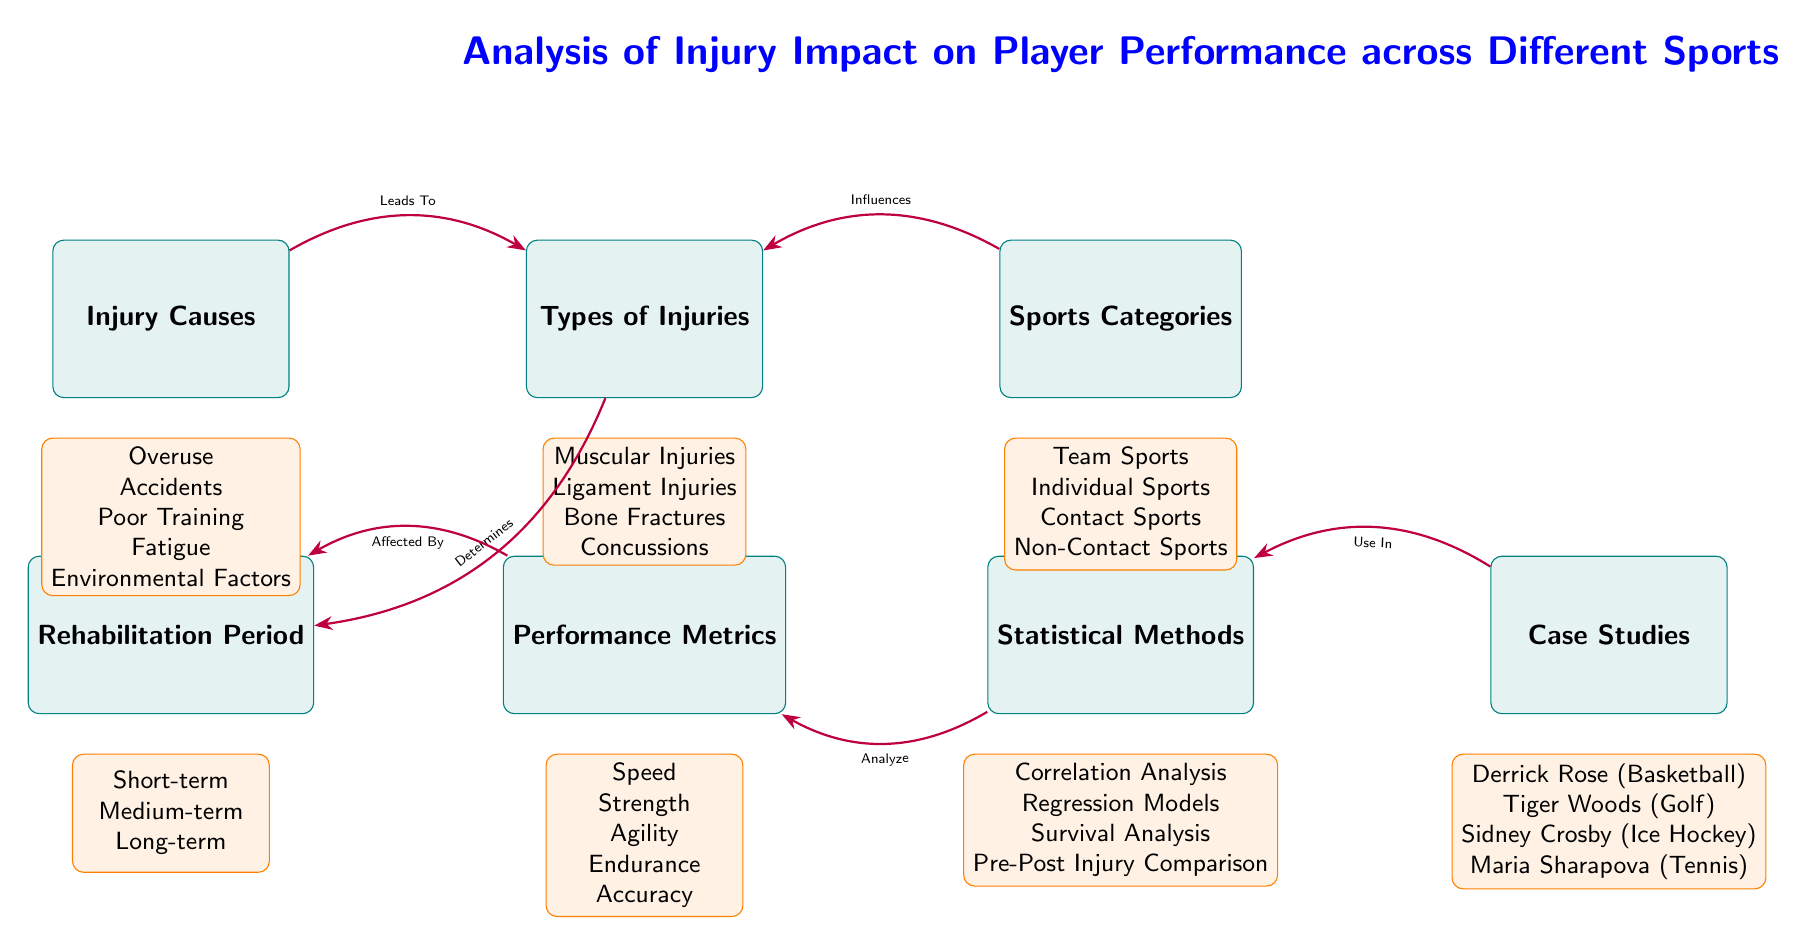What are the types of injuries mentioned in the diagram? The diagram lists four types of injuries: Muscular Injuries, Ligament Injuries, Bone Fractures, and Concussions.
Answer: Muscular Injuries, Ligament Injuries, Bone Fractures, Concussions How many sports categories are identified? The diagram identifies four sports categories: Team Sports, Individual Sports, Contact Sports, and Non-Contact Sports.
Answer: Four What performance metrics are affected by injuries? The diagram details five performance metrics: Speed, Strength, Agility, Endurance, and Accuracy.
Answer: Speed, Strength, Agility, Endurance, Accuracy What leads to injuries according to the diagram? The diagram shows that the causes of injuries include Overuse, Accidents, Poor Training, Fatigue, and Environmental Factors.
Answer: Overuse, Accidents, Poor Training, Fatigue, Environmental Factors How does rehabilitation period relate to performance metrics? The rehabilitation period affects performance metrics, which are also influenced by the types of injuries sustained. This relationship indicates that different rehabilitation approaches can impact various aspects of player performance.
Answer: Affected By Which case study is associated with basketball? The diagram names Derrick Rose as the case study associated with basketball.
Answer: Derrick Rose What type of analysis is used for performance metrics? The diagram lists four statistical methods for analyzing performance metrics: Correlation Analysis, Regression Models, Survival Analysis, and Pre-Post Injury Comparison.
Answer: Correlation Analysis, Regression Models, Survival Analysis, Pre-Post Injury Comparison What are the three lengths of rehabilitation periods displayed? The diagram categorizes rehabilitation periods into three types: Short-term, Medium-term, and Long-term.
Answer: Short-term, Medium-term, Long-term Which connection shows that sports categories influence injuries? The diagram illustrates the influence of sports categories on injuries with an arrow pointing from the Sports Categories node to the Types of Injuries node.
Answer: Influences How many edges are connecting the causes node to other nodes? There are two edges connecting the Causes node: one to the Injuries node and one to the Rehabilitation Period node. Therefore, it affects both types of injuries and the period for recovery.
Answer: Two 